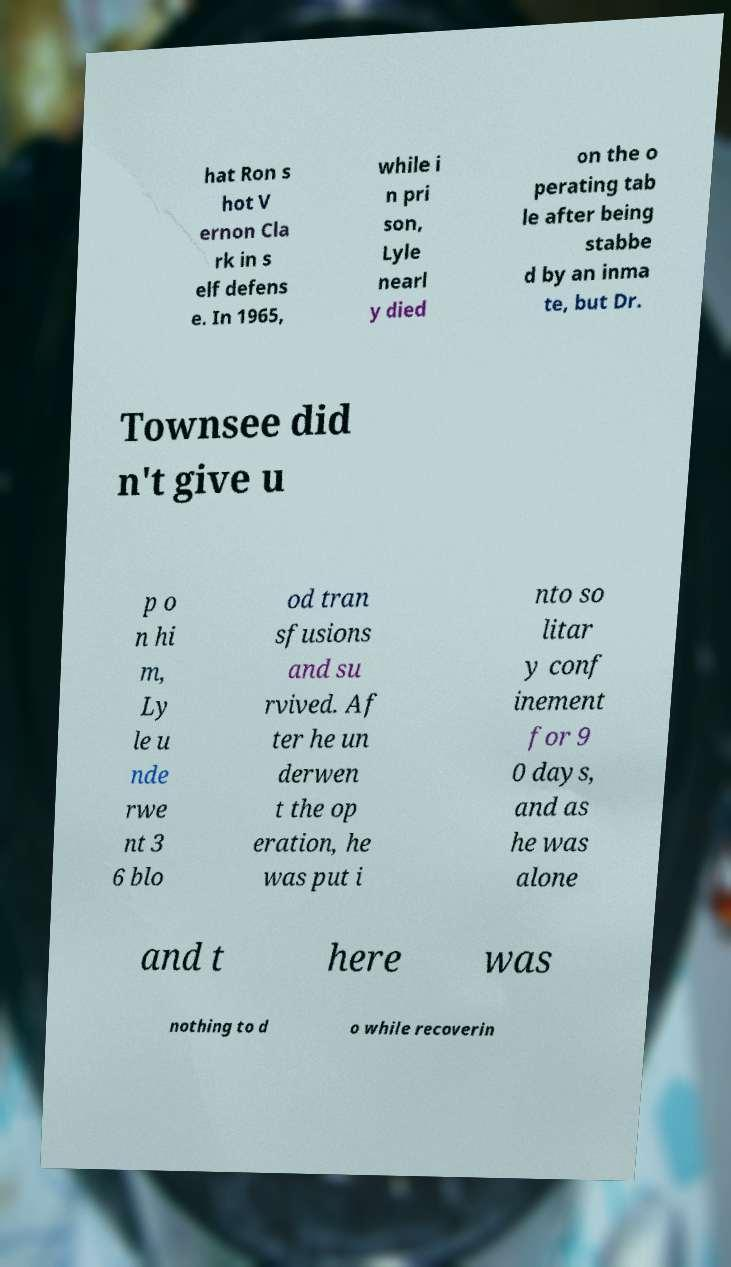Can you read and provide the text displayed in the image?This photo seems to have some interesting text. Can you extract and type it out for me? hat Ron s hot V ernon Cla rk in s elf defens e. In 1965, while i n pri son, Lyle nearl y died on the o perating tab le after being stabbe d by an inma te, but Dr. Townsee did n't give u p o n hi m, Ly le u nde rwe nt 3 6 blo od tran sfusions and su rvived. Af ter he un derwen t the op eration, he was put i nto so litar y conf inement for 9 0 days, and as he was alone and t here was nothing to d o while recoverin 